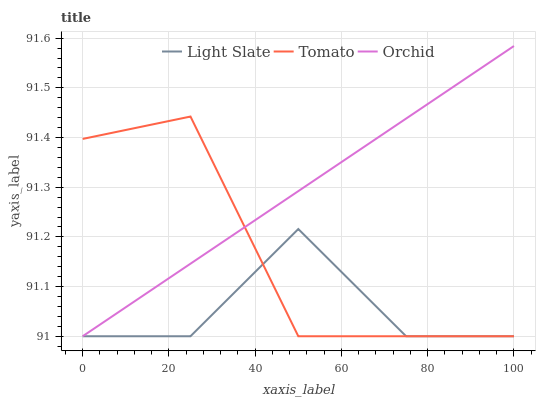Does Light Slate have the minimum area under the curve?
Answer yes or no. Yes. Does Orchid have the maximum area under the curve?
Answer yes or no. Yes. Does Tomato have the minimum area under the curve?
Answer yes or no. No. Does Tomato have the maximum area under the curve?
Answer yes or no. No. Is Orchid the smoothest?
Answer yes or no. Yes. Is Tomato the roughest?
Answer yes or no. Yes. Is Tomato the smoothest?
Answer yes or no. No. Is Orchid the roughest?
Answer yes or no. No. Does Light Slate have the lowest value?
Answer yes or no. Yes. Does Orchid have the highest value?
Answer yes or no. Yes. Does Tomato have the highest value?
Answer yes or no. No. Does Orchid intersect Light Slate?
Answer yes or no. Yes. Is Orchid less than Light Slate?
Answer yes or no. No. Is Orchid greater than Light Slate?
Answer yes or no. No. 